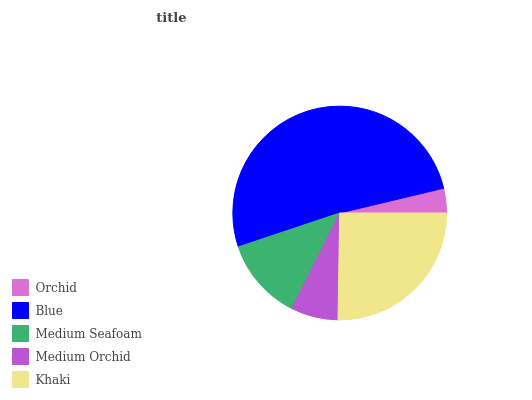Is Orchid the minimum?
Answer yes or no. Yes. Is Blue the maximum?
Answer yes or no. Yes. Is Medium Seafoam the minimum?
Answer yes or no. No. Is Medium Seafoam the maximum?
Answer yes or no. No. Is Blue greater than Medium Seafoam?
Answer yes or no. Yes. Is Medium Seafoam less than Blue?
Answer yes or no. Yes. Is Medium Seafoam greater than Blue?
Answer yes or no. No. Is Blue less than Medium Seafoam?
Answer yes or no. No. Is Medium Seafoam the high median?
Answer yes or no. Yes. Is Medium Seafoam the low median?
Answer yes or no. Yes. Is Medium Orchid the high median?
Answer yes or no. No. Is Khaki the low median?
Answer yes or no. No. 